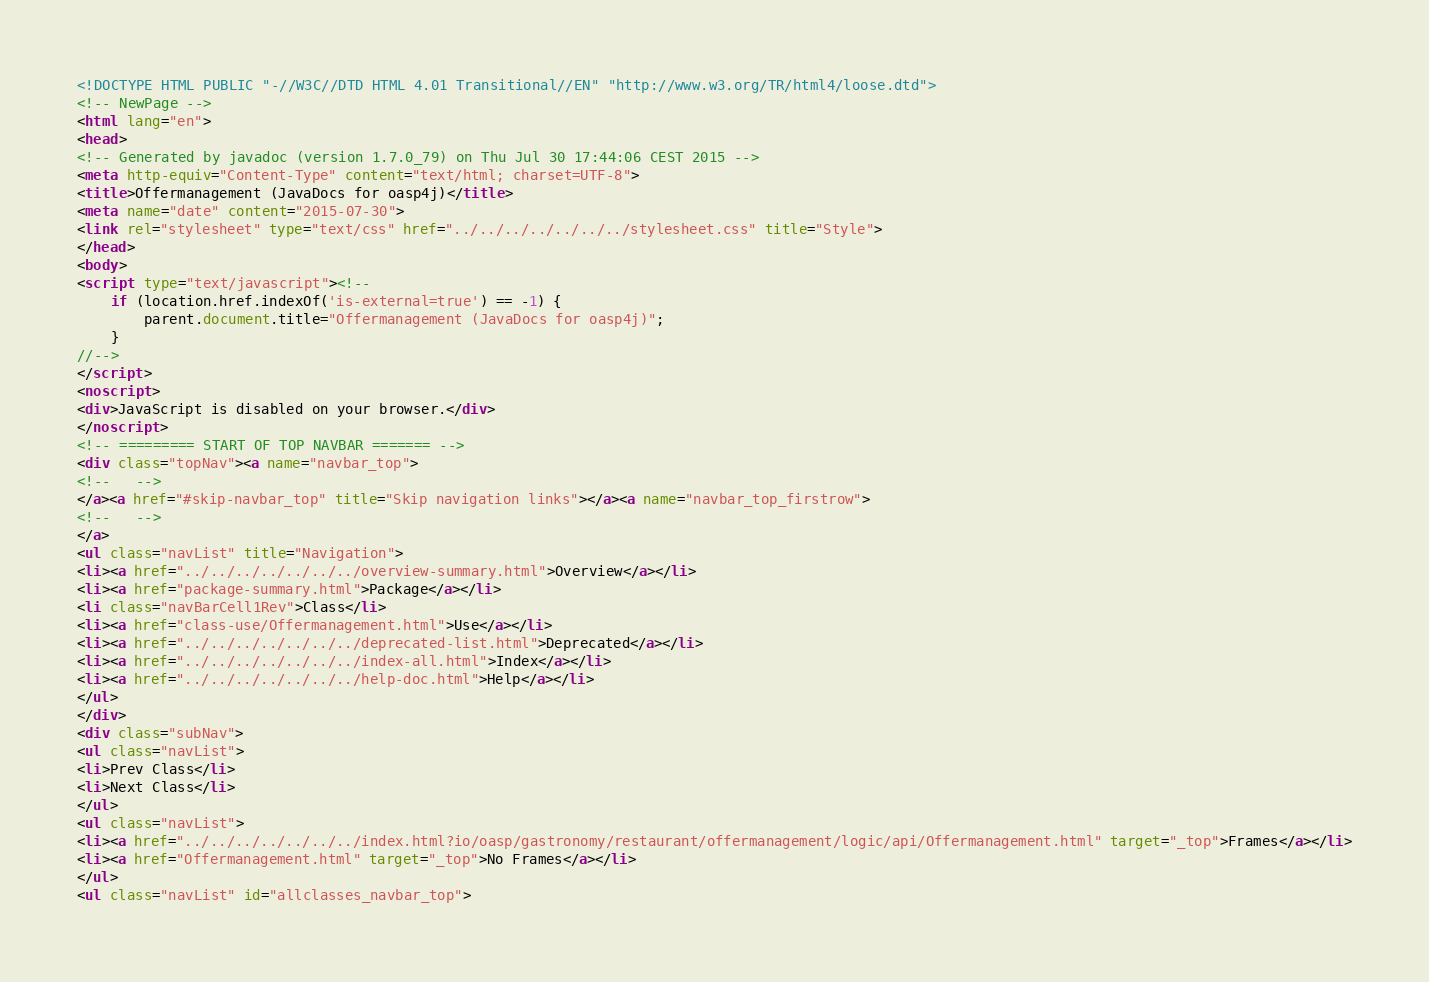<code> <loc_0><loc_0><loc_500><loc_500><_HTML_><!DOCTYPE HTML PUBLIC "-//W3C//DTD HTML 4.01 Transitional//EN" "http://www.w3.org/TR/html4/loose.dtd">
<!-- NewPage -->
<html lang="en">
<head>
<!-- Generated by javadoc (version 1.7.0_79) on Thu Jul 30 17:44:06 CEST 2015 -->
<meta http-equiv="Content-Type" content="text/html; charset=UTF-8">
<title>Offermanagement (JavaDocs for oasp4j)</title>
<meta name="date" content="2015-07-30">
<link rel="stylesheet" type="text/css" href="../../../../../../../stylesheet.css" title="Style">
</head>
<body>
<script type="text/javascript"><!--
    if (location.href.indexOf('is-external=true') == -1) {
        parent.document.title="Offermanagement (JavaDocs for oasp4j)";
    }
//-->
</script>
<noscript>
<div>JavaScript is disabled on your browser.</div>
</noscript>
<!-- ========= START OF TOP NAVBAR ======= -->
<div class="topNav"><a name="navbar_top">
<!--   -->
</a><a href="#skip-navbar_top" title="Skip navigation links"></a><a name="navbar_top_firstrow">
<!--   -->
</a>
<ul class="navList" title="Navigation">
<li><a href="../../../../../../../overview-summary.html">Overview</a></li>
<li><a href="package-summary.html">Package</a></li>
<li class="navBarCell1Rev">Class</li>
<li><a href="class-use/Offermanagement.html">Use</a></li>
<li><a href="../../../../../../../deprecated-list.html">Deprecated</a></li>
<li><a href="../../../../../../../index-all.html">Index</a></li>
<li><a href="../../../../../../../help-doc.html">Help</a></li>
</ul>
</div>
<div class="subNav">
<ul class="navList">
<li>Prev Class</li>
<li>Next Class</li>
</ul>
<ul class="navList">
<li><a href="../../../../../../../index.html?io/oasp/gastronomy/restaurant/offermanagement/logic/api/Offermanagement.html" target="_top">Frames</a></li>
<li><a href="Offermanagement.html" target="_top">No Frames</a></li>
</ul>
<ul class="navList" id="allclasses_navbar_top"></code> 